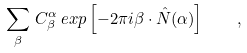Convert formula to latex. <formula><loc_0><loc_0><loc_500><loc_500>\sum _ { \beta } \, C _ { \beta } ^ { \alpha } \, e x p \left [ - 2 \pi i \beta \cdot \hat { N } ( \alpha ) \right ] \quad ,</formula> 